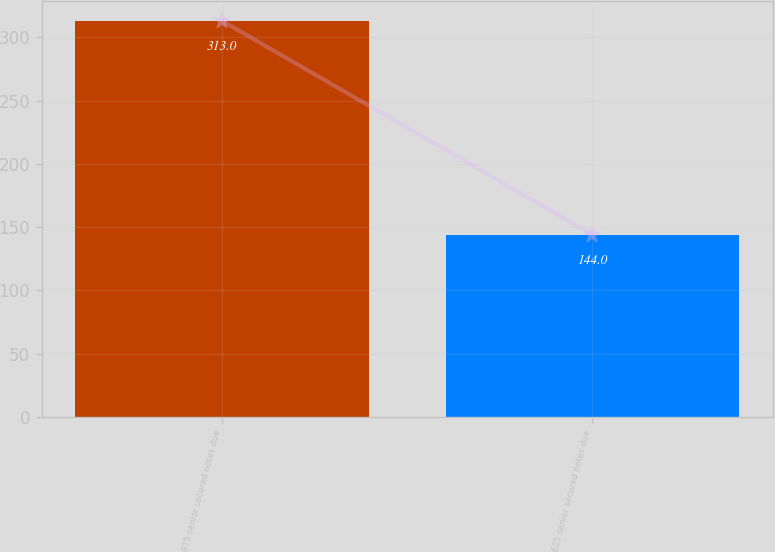<chart> <loc_0><loc_0><loc_500><loc_500><bar_chart><fcel>975 senior secured notes due<fcel>625 senior secured notes due<nl><fcel>313<fcel>144<nl></chart> 